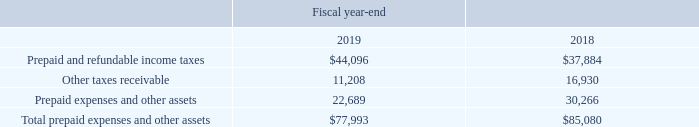9. BALANCE SHEET DETAILS
Prepaid expenses and other assets consist of the following (in thousands):
What was the Other taxes receivable in 2019?
Answer scale should be: thousand. 11,208. What was the  Prepaid expenses and other assets in 2018?
Answer scale should be: thousand. 30,266. In which year was Total prepaid expenses and other assets calculated? 2019, 2018. In which year was Other taxes receivable larger? 16,930>11,208
Answer: 2018. What was the change in Prepaid and refundable income taxes from 2018 to 2019?
Answer scale should be: thousand. 44,096-37,884
Answer: 6212. What was the percentage change in Prepaid and refundable income taxes from 2018 to 2019?
Answer scale should be: percent. (44,096-37,884)/37,884
Answer: 16.4. 